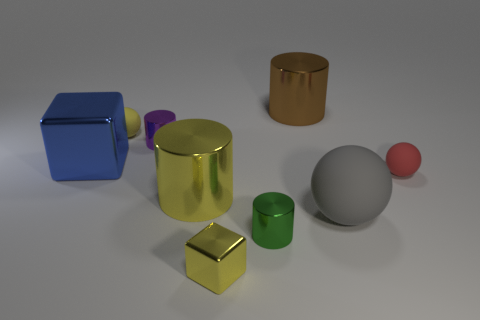The gray thing has what size?
Give a very brief answer. Large. Are the yellow cylinder and the large blue cube made of the same material?
Give a very brief answer. Yes. There is a object that is on the left side of the rubber thing that is behind the big metal block; what number of big metallic cylinders are in front of it?
Provide a short and direct response. 1. There is a small red rubber object that is right of the yellow shiny cylinder; what shape is it?
Provide a short and direct response. Sphere. What number of other objects are there of the same material as the yellow ball?
Keep it short and to the point. 2. Is the color of the large sphere the same as the large metal cube?
Offer a terse response. No. Are there fewer yellow cylinders on the left side of the large metal cube than tiny rubber spheres behind the purple thing?
Keep it short and to the point. Yes. What is the color of the other tiny shiny object that is the same shape as the tiny green thing?
Make the answer very short. Purple. There is a yellow object that is in front of the green metal thing; is it the same size as the yellow rubber ball?
Give a very brief answer. Yes. Are there fewer big shiny blocks right of the small red matte thing than blue rubber cylinders?
Make the answer very short. No. 